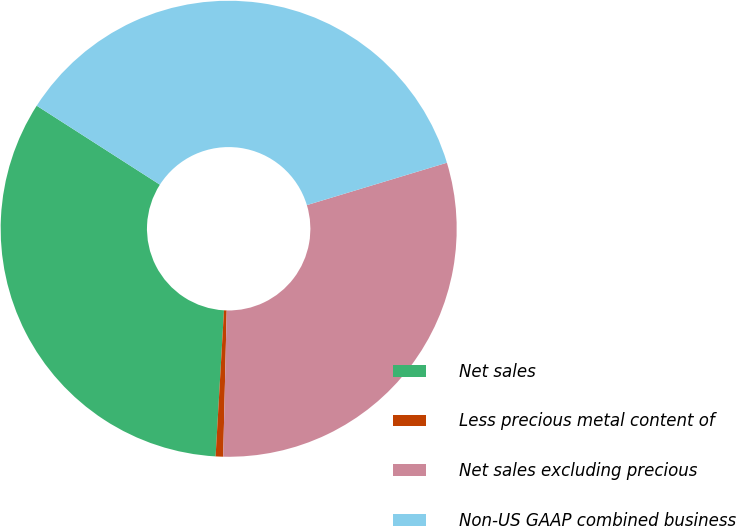Convert chart to OTSL. <chart><loc_0><loc_0><loc_500><loc_500><pie_chart><fcel>Net sales<fcel>Less precious metal content of<fcel>Net sales excluding precious<fcel>Non-US GAAP combined business<nl><fcel>33.16%<fcel>0.53%<fcel>30.06%<fcel>36.25%<nl></chart> 